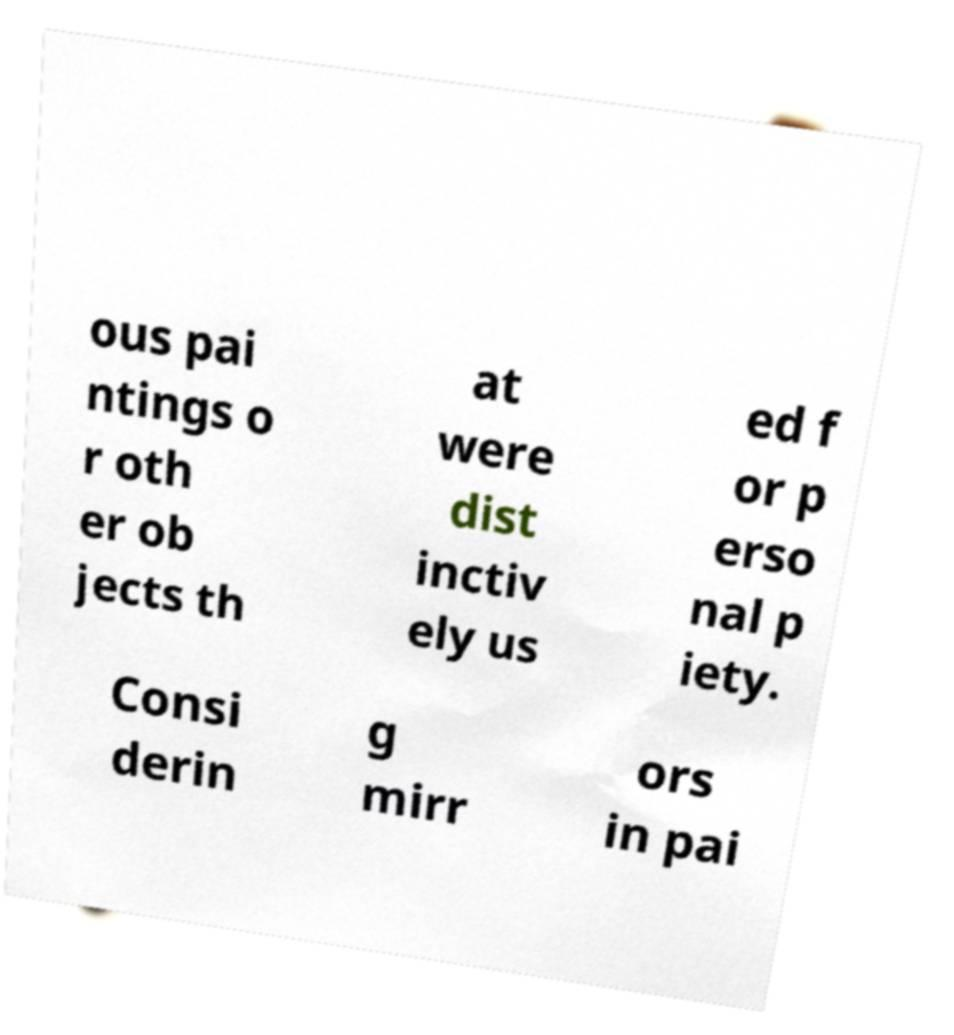Could you extract and type out the text from this image? ous pai ntings o r oth er ob jects th at were dist inctiv ely us ed f or p erso nal p iety. Consi derin g mirr ors in pai 